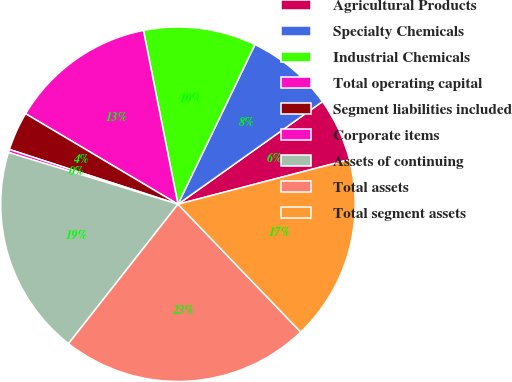Convert chart to OTSL. <chart><loc_0><loc_0><loc_500><loc_500><pie_chart><fcel>Agricultural Products<fcel>Specialty Chemicals<fcel>Industrial Chemicals<fcel>Total operating capital<fcel>Segment liabilities included<fcel>Corporate items<fcel>Assets of continuing<fcel>Total assets<fcel>Total segment assets<nl><fcel>5.77%<fcel>8.02%<fcel>10.27%<fcel>13.35%<fcel>3.53%<fcel>0.28%<fcel>19.13%<fcel>22.77%<fcel>16.88%<nl></chart> 